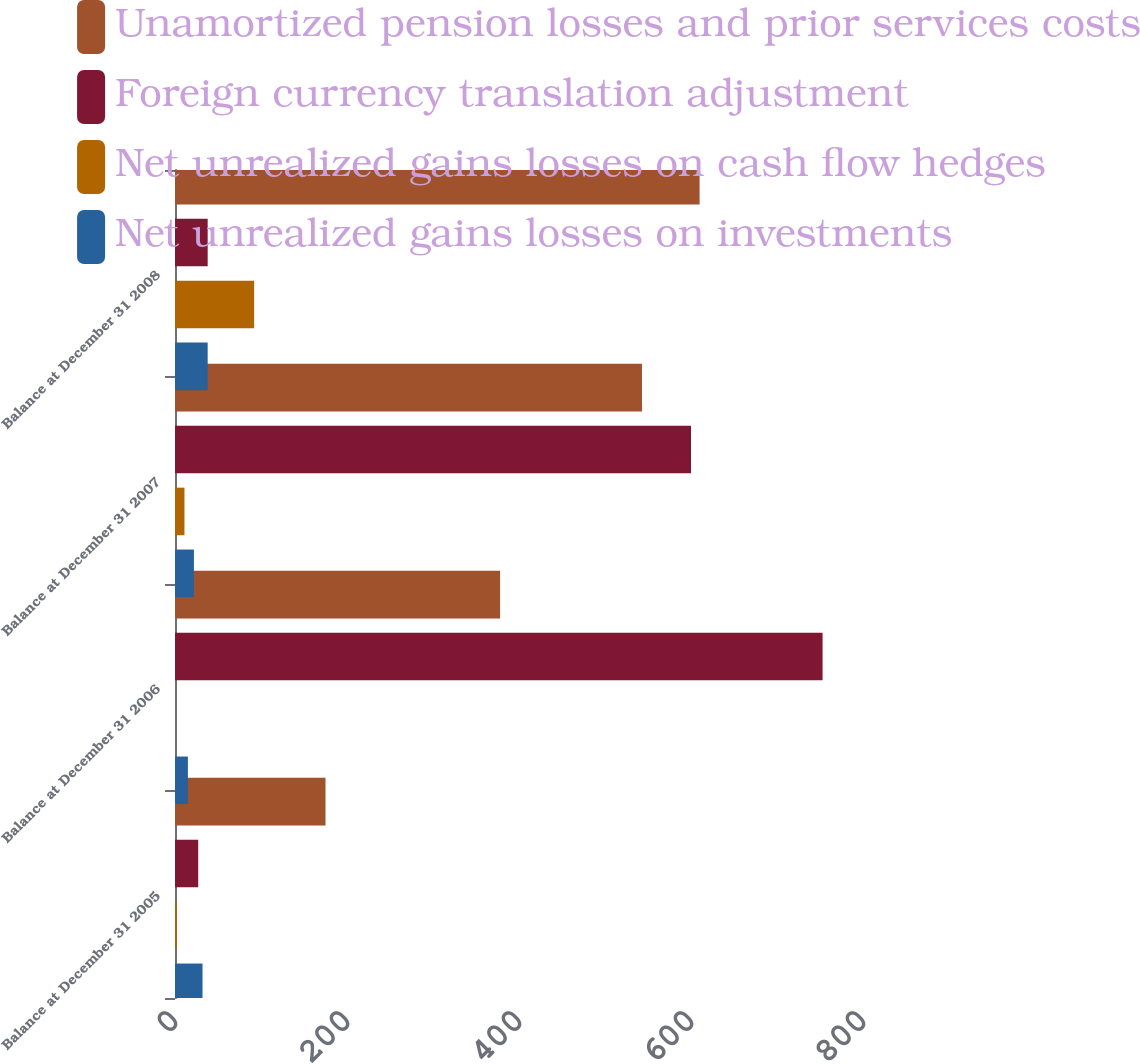Convert chart. <chart><loc_0><loc_0><loc_500><loc_500><stacked_bar_chart><ecel><fcel>Balance at December 31 2005<fcel>Balance at December 31 2006<fcel>Balance at December 31 2007<fcel>Balance at December 31 2008<nl><fcel>Unamortized pension losses and prior services costs<fcel>175<fcel>378<fcel>543<fcel>610<nl><fcel>Foreign currency translation adjustment<fcel>27<fcel>753<fcel>600<fcel>38<nl><fcel>Net unrealized gains losses on cash flow hedges<fcel>2<fcel>0<fcel>11<fcel>92<nl><fcel>Net unrealized gains losses on investments<fcel>32<fcel>15<fcel>22<fcel>38<nl></chart> 